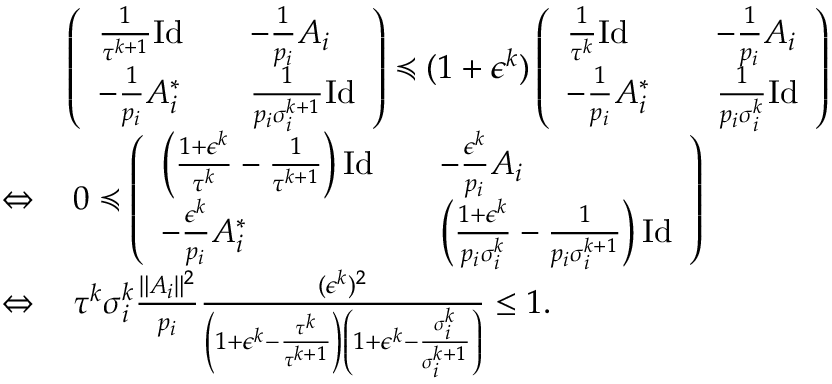<formula> <loc_0><loc_0><loc_500><loc_500>\begin{array} { r l } & { \left ( \begin{array} { l l l } { \frac { 1 } { \tau ^ { k + 1 } } I d } & & { - \frac { 1 } { p _ { i } } A _ { i } } \\ { - \frac { 1 } { p _ { i } } A _ { i } ^ { * } } & & { \frac { 1 } { p _ { i } \sigma _ { i } ^ { k + 1 } } I d } \end{array} \right ) \prec c u r l y e q ( 1 + \epsilon ^ { k } ) \left ( \begin{array} { l l l } { \frac { 1 } { \tau ^ { k } } I d } & & { - \frac { 1 } { p _ { i } } A _ { i } } \\ { - \frac { 1 } { p _ { i } } A _ { i } ^ { * } } & & { \frac { 1 } { p _ { i } \sigma _ { i } ^ { k } } I d } \end{array} \right ) } \\ { \Leftrightarrow } & { \, 0 \prec c u r l y e q \left ( \begin{array} { l l l } { \left ( \frac { 1 + \epsilon ^ { k } } { \tau ^ { k } } - \frac { 1 } { \tau ^ { k + 1 } } \right ) I d } & & { - \frac { \epsilon ^ { k } } { p _ { i } } A _ { i } } \\ { - \frac { \epsilon ^ { k } } { p _ { i } } A _ { i } ^ { * } } & & { \left ( \frac { 1 + \epsilon ^ { k } } { p _ { i } \sigma _ { i } ^ { k } } - \frac { 1 } { p _ { i } \sigma _ { i } ^ { k + 1 } } \right ) I d } \end{array} \right ) } \\ { \Leftrightarrow } & { \, \tau ^ { k } \sigma _ { i } ^ { k } \frac { \| A _ { i } \| ^ { 2 } } { p _ { i } } \frac { ( \epsilon ^ { k } ) ^ { 2 } } { \left ( 1 + \epsilon ^ { k } - \frac { \tau ^ { k } } { \tau ^ { k + 1 } } \right ) \left ( 1 + \epsilon ^ { k } - \frac { \sigma _ { i } ^ { k } } { \sigma _ { i } ^ { k + 1 } } \right ) } \leq 1 . } \end{array}</formula> 